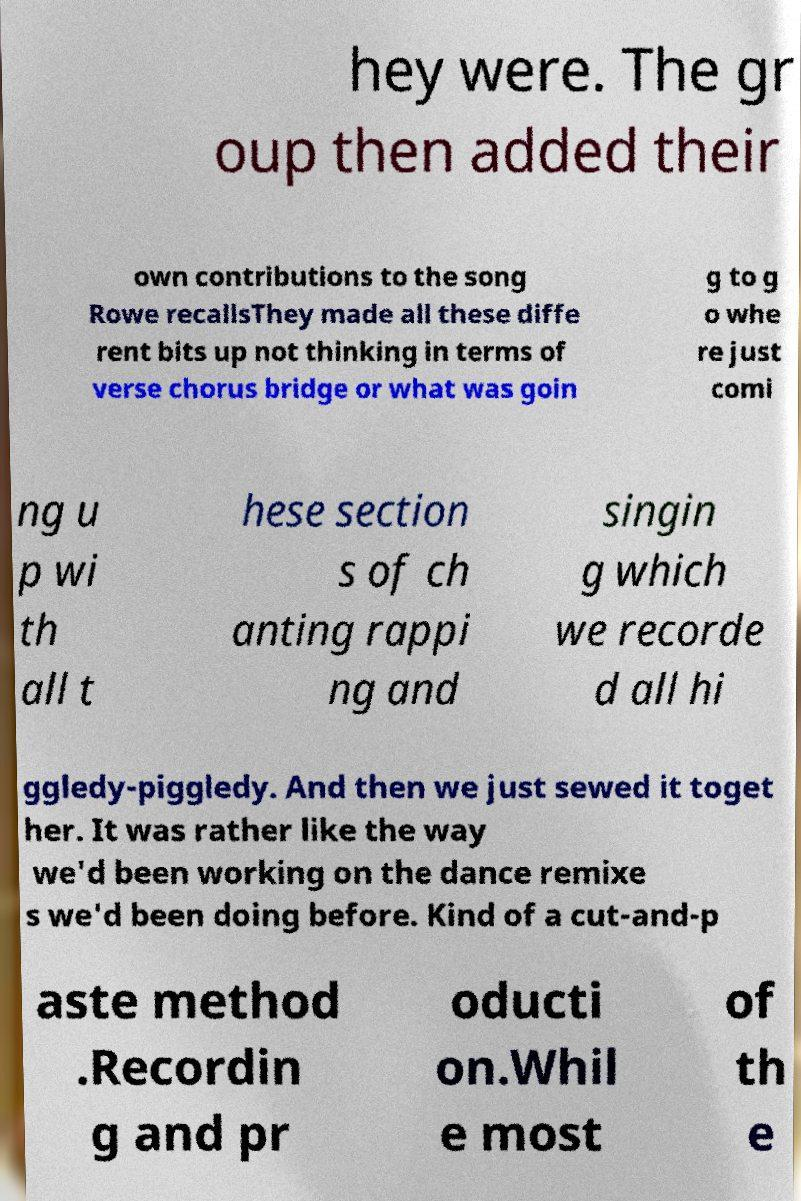For documentation purposes, I need the text within this image transcribed. Could you provide that? hey were. The gr oup then added their own contributions to the song Rowe recallsThey made all these diffe rent bits up not thinking in terms of verse chorus bridge or what was goin g to g o whe re just comi ng u p wi th all t hese section s of ch anting rappi ng and singin g which we recorde d all hi ggledy-piggledy. And then we just sewed it toget her. It was rather like the way we'd been working on the dance remixe s we'd been doing before. Kind of a cut-and-p aste method .Recordin g and pr oducti on.Whil e most of th e 